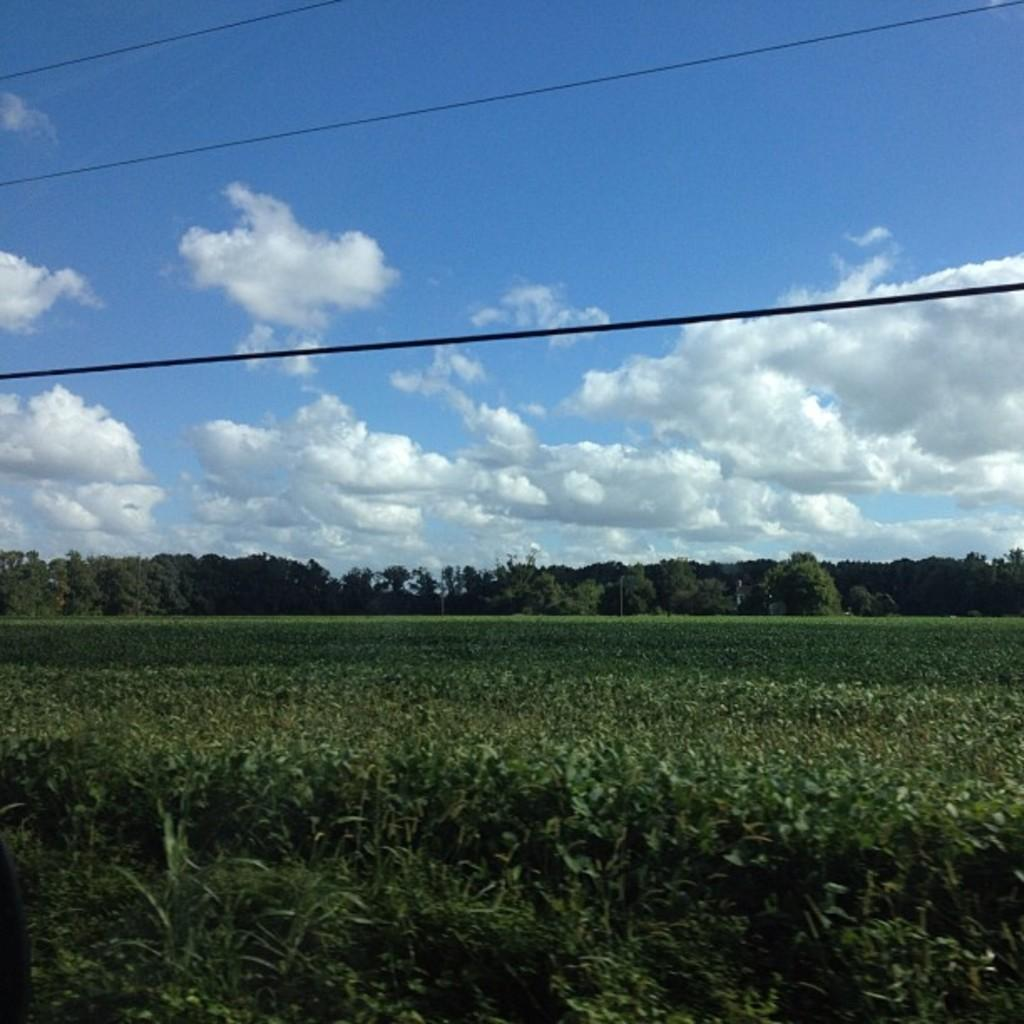What type of vegetation can be seen in the image? There are trees and plants in the image. What else can be seen in the image besides vegetation? Cables are visible in the image. What is visible in the background of the image? The sky is visible in the image. What type of nose can be seen on the tree in the image? There is no nose present on the trees in the image, as trees do not have noses. 